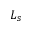Convert formula to latex. <formula><loc_0><loc_0><loc_500><loc_500>L _ { s }</formula> 